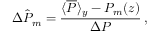<formula> <loc_0><loc_0><loc_500><loc_500>\hat { \Delta P _ { m } } = \frac { \langle \overline { P } \rangle _ { y } - P _ { m } ( z ) } { \Delta P } \, ,</formula> 